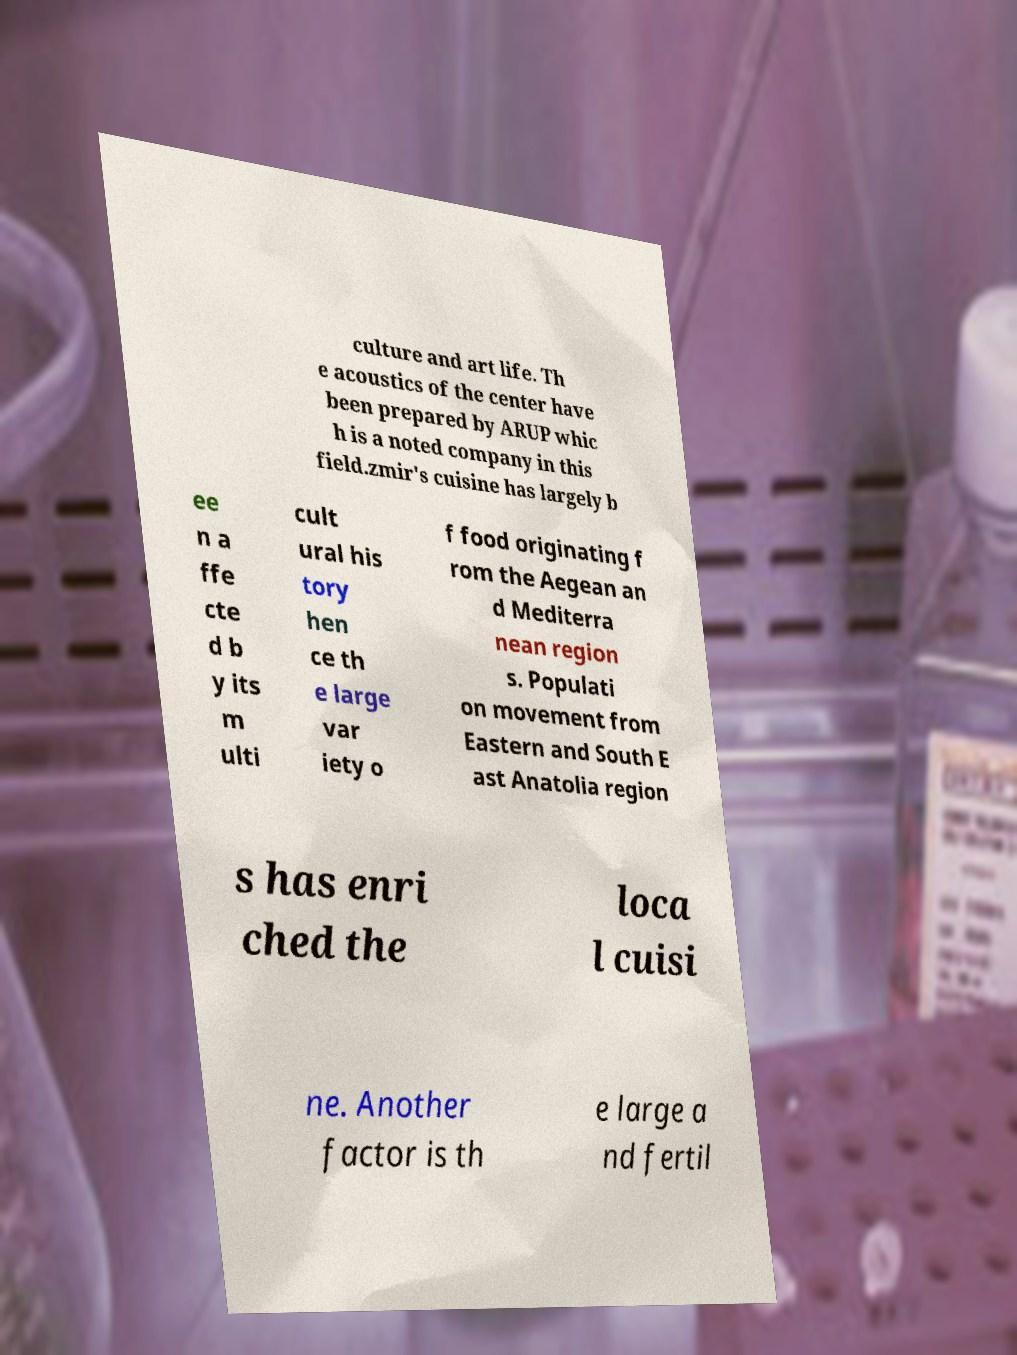I need the written content from this picture converted into text. Can you do that? culture and art life. Th e acoustics of the center have been prepared by ARUP whic h is a noted company in this field.zmir's cuisine has largely b ee n a ffe cte d b y its m ulti cult ural his tory hen ce th e large var iety o f food originating f rom the Aegean an d Mediterra nean region s. Populati on movement from Eastern and South E ast Anatolia region s has enri ched the loca l cuisi ne. Another factor is th e large a nd fertil 